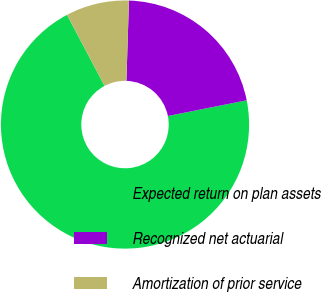Convert chart to OTSL. <chart><loc_0><loc_0><loc_500><loc_500><pie_chart><fcel>Expected return on plan assets<fcel>Recognized net actuarial<fcel>Amortization of prior service<nl><fcel>70.39%<fcel>21.36%<fcel>8.25%<nl></chart> 